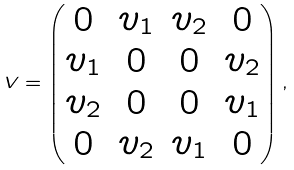Convert formula to latex. <formula><loc_0><loc_0><loc_500><loc_500>V = \begin{pmatrix} 0 & v _ { 1 } & v _ { 2 } & 0 \\ v _ { 1 } & 0 & 0 & v _ { 2 } \\ v _ { 2 } & 0 & 0 & v _ { 1 } \\ 0 & v _ { 2 } & v _ { 1 } & 0 \end{pmatrix} ,</formula> 